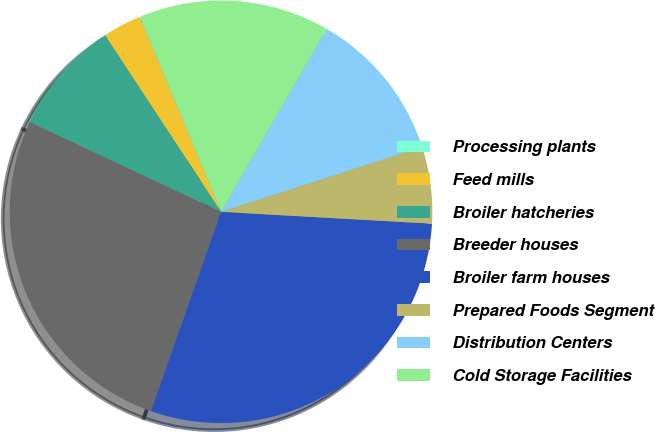<chart> <loc_0><loc_0><loc_500><loc_500><pie_chart><fcel>Processing plants<fcel>Feed mills<fcel>Broiler hatcheries<fcel>Breeder houses<fcel>Broiler farm houses<fcel>Prepared Foods Segment<fcel>Distribution Centers<fcel>Cold Storage Facilities<nl><fcel>0.04%<fcel>2.95%<fcel>8.77%<fcel>26.59%<fcel>29.5%<fcel>5.86%<fcel>11.69%<fcel>14.6%<nl></chart> 